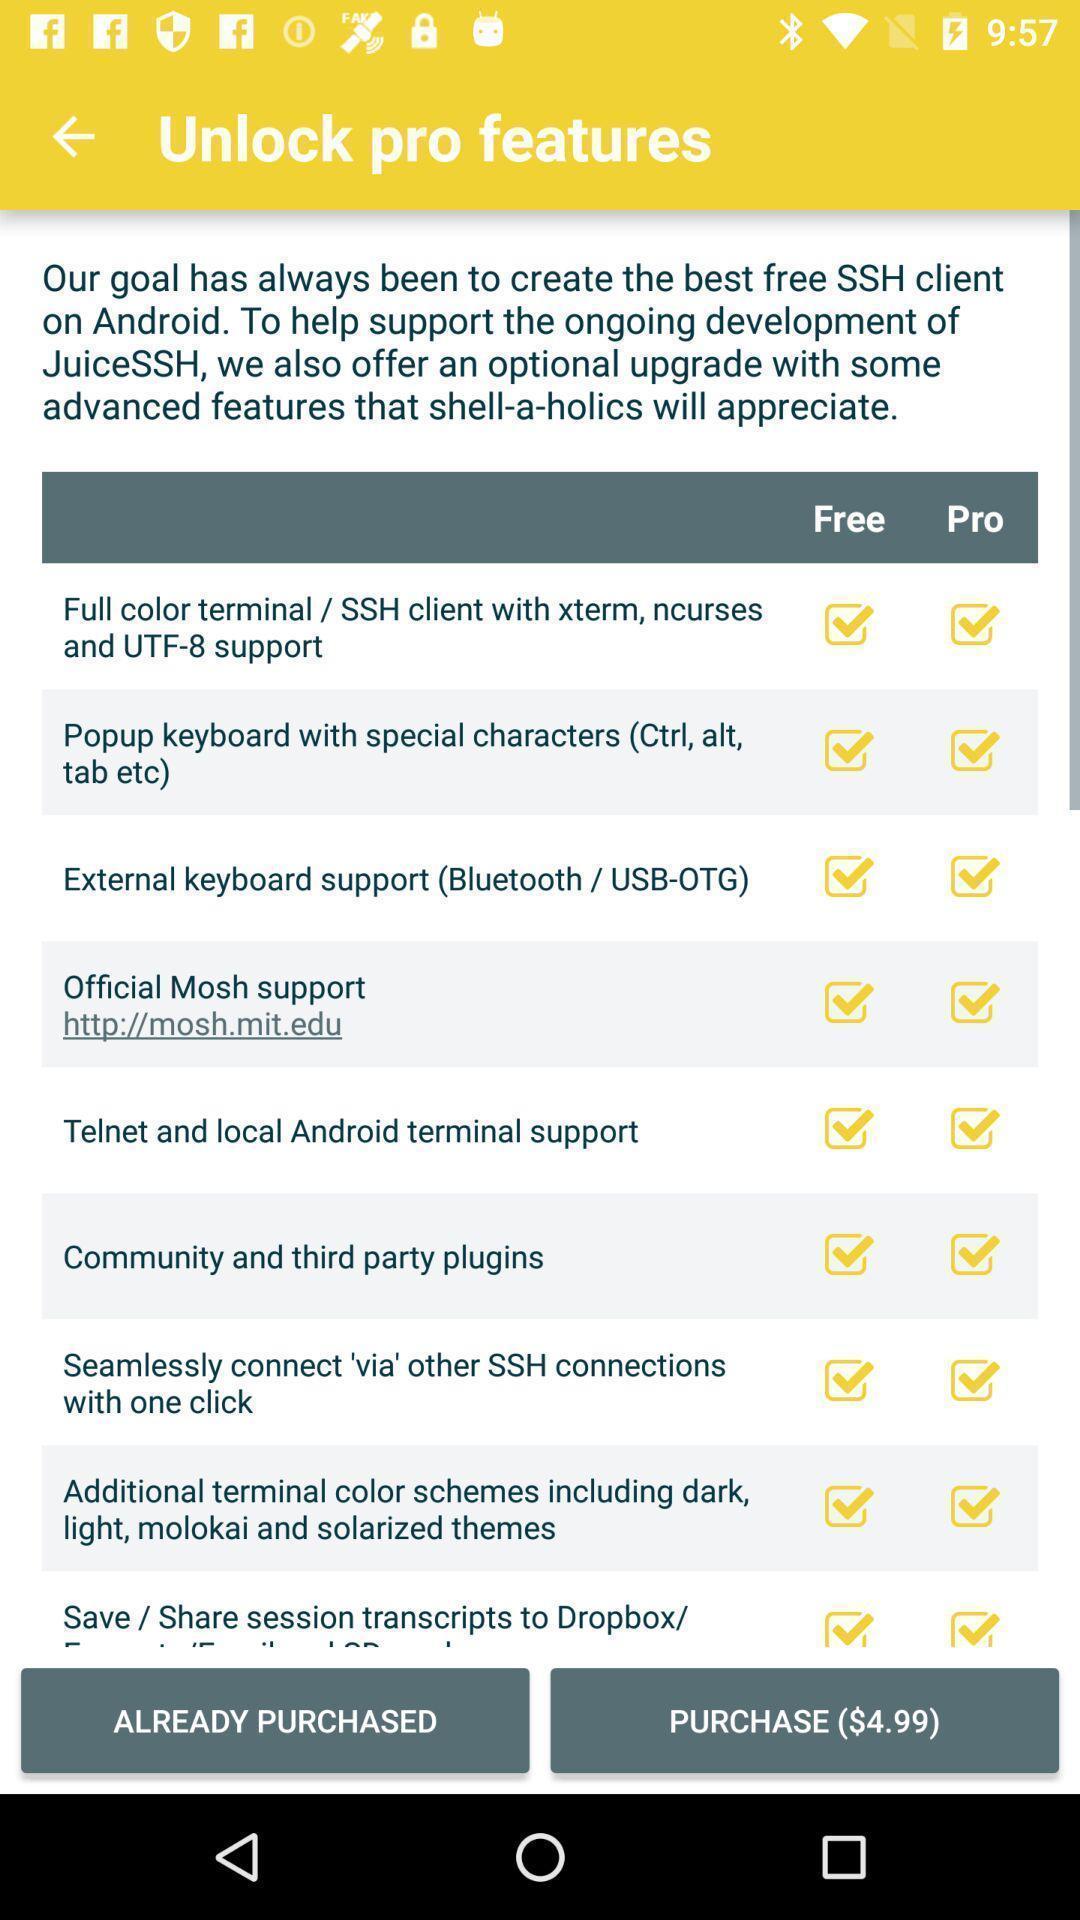What details can you identify in this image? Page that displaying features settings. 